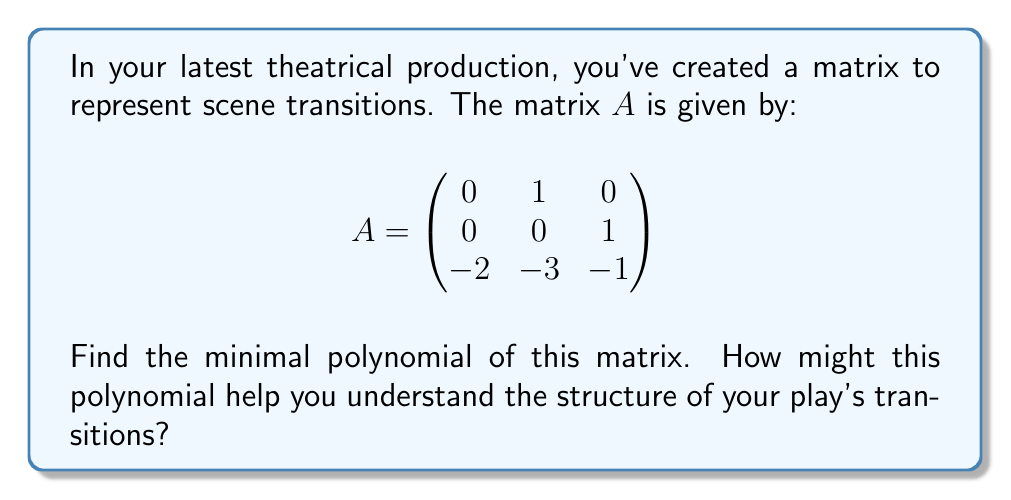Could you help me with this problem? To find the minimal polynomial of matrix $A$, we'll follow these steps:

1) First, calculate the characteristic polynomial of $A$:
   $p(x) = \det(xI - A)$
   
   $$\det\begin{pmatrix}
   x & -1 & 0 \\
   0 & x & -1 \\
   2 & 3 & x+1
   \end{pmatrix}$$
   
   $p(x) = x(x(x+1) + 3) + 2 = x^3 + x^2 + 3x + 2$

2) The minimal polynomial divides the characteristic polynomial, so it could be $p(x)$, $(x+1)(x^2+3)$, $(x+2)(x^2-x+1)$, or a linear factor.

3) Let's check if $A$ satisfies its characteristic equation:
   $A^3 + A^2 + 3A + 2I = 0$
   
   If this equality holds, then the minimal polynomial is the same as the characteristic polynomial.

4) Calculate $A^2$:
   $$A^2 = \begin{pmatrix}
   0 & 0 & 1 \\
   -2 & -3 & -1 \\
   -2 & -3 & -3
   \end{pmatrix}$$

5) Calculate $A^3$:
   $$A^3 = \begin{pmatrix}
   -2 & -3 & -1 \\
   -2 & -3 & -3 \\
   2 & 3 & 3
   \end{pmatrix}$$

6) Now, let's verify $A^3 + A^2 + 3A + 2I = 0$:
   $$\begin{pmatrix}
   -2 & -3 & -1 \\
   -2 & -3 & -3 \\
   2 & 3 & 3
   \end{pmatrix} + 
   \begin{pmatrix}
   0 & 0 & 1 \\
   -2 & -3 & -1 \\
   -2 & -3 & -3
   \end{pmatrix} + 
   3\begin{pmatrix}
   0 & 1 & 0 \\
   0 & 0 & 1 \\
   -2 & -3 & -1
   \end{pmatrix} +
   2\begin{pmatrix}
   1 & 0 & 0 \\
   0 & 1 & 0 \\
   0 & 0 & 1
   \end{pmatrix} = 0$$

   This equality holds, confirming that the minimal polynomial is the same as the characteristic polynomial.

7) Therefore, the minimal polynomial is $m(x) = x^3 + x^2 + 3x + 2$.

This polynomial can help understand the structure of the play's transitions by revealing the cyclic nature of the scenes. The degree of the polynomial (3) suggests that the play has three distinct "states" or themes that it cycles through. The coefficients indicate how these states interact and transition between each other.
Answer: $m(x) = x^3 + x^2 + 3x + 2$ 